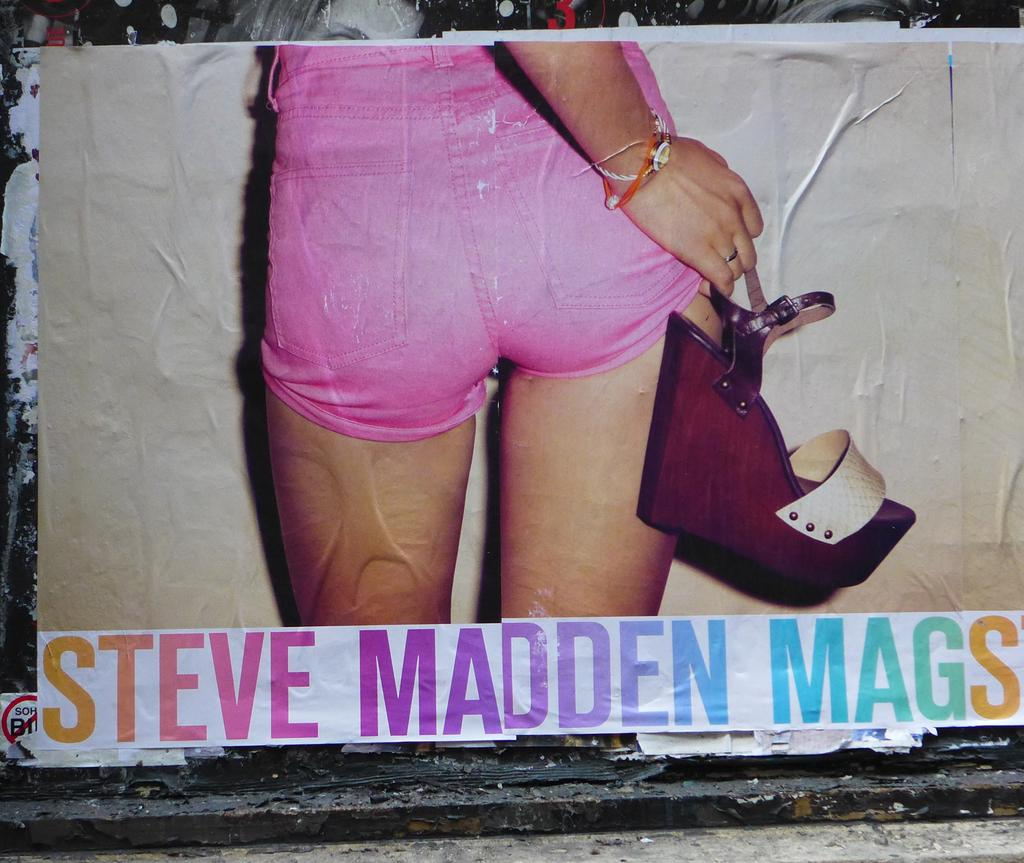What is the main subject of the poster in the image? The poster features a person holding a footwear. What can be seen in the person's hand in the poster? The person is holding a footwear in their hand. Is there any text on the poster? Yes, there is text written at the bottom of the poster. How does the fog affect the visibility of the poster in the image? There is no fog present in the image, so it does not affect the visibility of the poster. Are there any bears visible in the image? No, there are no bears present in the image. 